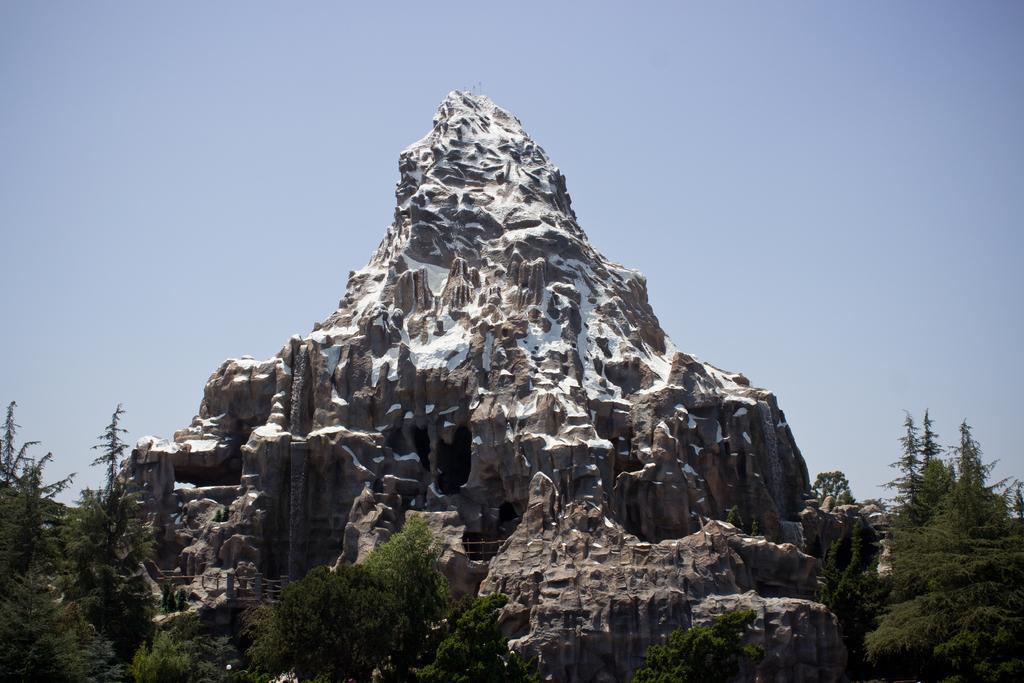Can you describe this image briefly? In the center of the image we can see a rock. At the bottom there are trees. In the background there is sky. 